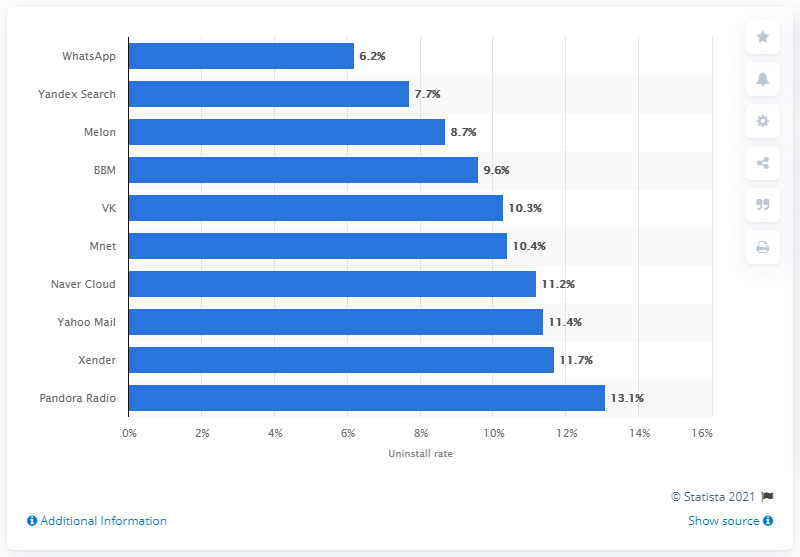Give some essential details in this illustration. In the preceding 24 months, 6.2% of WhatsApp users had uninstalled the app. 